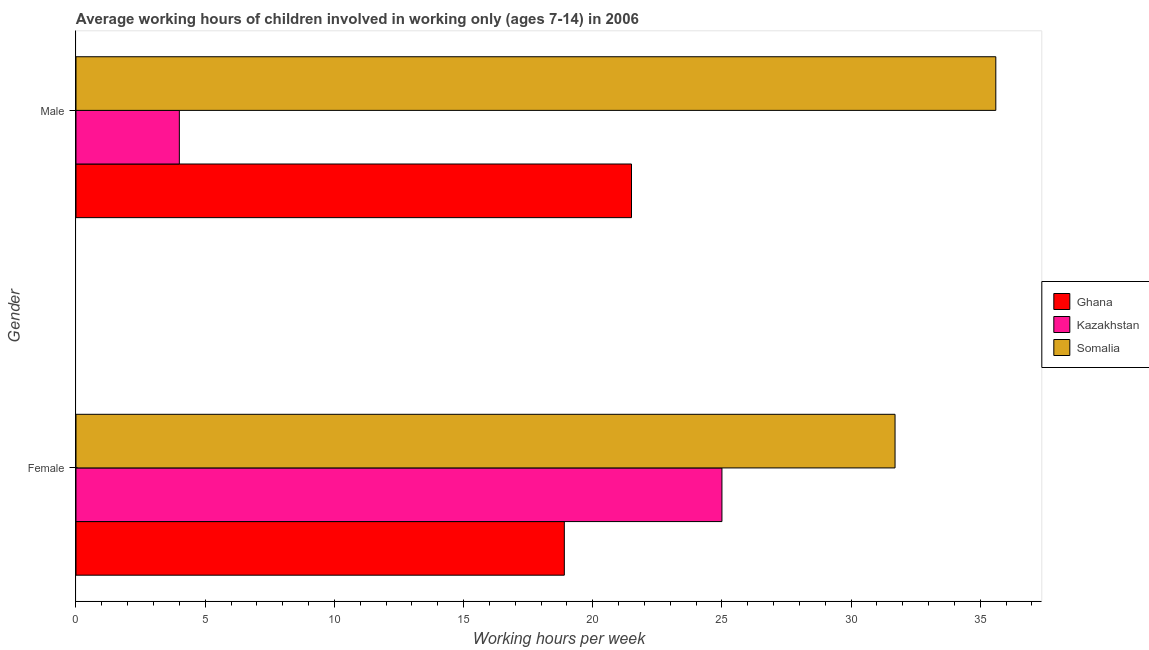Are the number of bars on each tick of the Y-axis equal?
Make the answer very short. Yes. How many bars are there on the 2nd tick from the bottom?
Offer a very short reply. 3. What is the label of the 1st group of bars from the top?
Give a very brief answer. Male. What is the average working hour of female children in Kazakhstan?
Your answer should be compact. 25. Across all countries, what is the maximum average working hour of male children?
Ensure brevity in your answer.  35.6. In which country was the average working hour of female children maximum?
Your answer should be very brief. Somalia. What is the total average working hour of female children in the graph?
Your response must be concise. 75.6. What is the difference between the average working hour of male children in Somalia and that in Kazakhstan?
Your answer should be compact. 31.6. What is the difference between the average working hour of male children in Kazakhstan and the average working hour of female children in Somalia?
Give a very brief answer. -27.7. What is the average average working hour of female children per country?
Provide a short and direct response. 25.2. What is the difference between the average working hour of male children and average working hour of female children in Ghana?
Make the answer very short. 2.6. What is the ratio of the average working hour of male children in Somalia to that in Ghana?
Keep it short and to the point. 1.66. In how many countries, is the average working hour of female children greater than the average average working hour of female children taken over all countries?
Your answer should be very brief. 1. What does the 3rd bar from the top in Male represents?
Provide a short and direct response. Ghana. What does the 3rd bar from the bottom in Female represents?
Your response must be concise. Somalia. How many bars are there?
Provide a short and direct response. 6. What is the difference between two consecutive major ticks on the X-axis?
Your answer should be compact. 5. Are the values on the major ticks of X-axis written in scientific E-notation?
Offer a terse response. No. Where does the legend appear in the graph?
Make the answer very short. Center right. How many legend labels are there?
Offer a terse response. 3. How are the legend labels stacked?
Provide a short and direct response. Vertical. What is the title of the graph?
Make the answer very short. Average working hours of children involved in working only (ages 7-14) in 2006. What is the label or title of the X-axis?
Offer a terse response. Working hours per week. What is the label or title of the Y-axis?
Keep it short and to the point. Gender. What is the Working hours per week in Kazakhstan in Female?
Ensure brevity in your answer.  25. What is the Working hours per week in Somalia in Female?
Provide a succinct answer. 31.7. What is the Working hours per week of Kazakhstan in Male?
Make the answer very short. 4. What is the Working hours per week of Somalia in Male?
Provide a short and direct response. 35.6. Across all Gender, what is the maximum Working hours per week of Ghana?
Make the answer very short. 21.5. Across all Gender, what is the maximum Working hours per week of Somalia?
Offer a very short reply. 35.6. Across all Gender, what is the minimum Working hours per week in Kazakhstan?
Your response must be concise. 4. Across all Gender, what is the minimum Working hours per week of Somalia?
Provide a short and direct response. 31.7. What is the total Working hours per week of Ghana in the graph?
Give a very brief answer. 40.4. What is the total Working hours per week of Somalia in the graph?
Make the answer very short. 67.3. What is the difference between the Working hours per week in Ghana in Female and the Working hours per week in Kazakhstan in Male?
Provide a short and direct response. 14.9. What is the difference between the Working hours per week in Ghana in Female and the Working hours per week in Somalia in Male?
Give a very brief answer. -16.7. What is the difference between the Working hours per week in Kazakhstan in Female and the Working hours per week in Somalia in Male?
Provide a succinct answer. -10.6. What is the average Working hours per week of Ghana per Gender?
Provide a short and direct response. 20.2. What is the average Working hours per week of Kazakhstan per Gender?
Provide a succinct answer. 14.5. What is the average Working hours per week in Somalia per Gender?
Your answer should be very brief. 33.65. What is the difference between the Working hours per week in Ghana and Working hours per week in Somalia in Male?
Your response must be concise. -14.1. What is the difference between the Working hours per week of Kazakhstan and Working hours per week of Somalia in Male?
Your response must be concise. -31.6. What is the ratio of the Working hours per week in Ghana in Female to that in Male?
Give a very brief answer. 0.88. What is the ratio of the Working hours per week of Kazakhstan in Female to that in Male?
Keep it short and to the point. 6.25. What is the ratio of the Working hours per week of Somalia in Female to that in Male?
Offer a terse response. 0.89. What is the difference between the highest and the second highest Working hours per week in Ghana?
Offer a terse response. 2.6. What is the difference between the highest and the second highest Working hours per week of Kazakhstan?
Provide a succinct answer. 21. What is the difference between the highest and the lowest Working hours per week of Ghana?
Ensure brevity in your answer.  2.6. What is the difference between the highest and the lowest Working hours per week in Kazakhstan?
Give a very brief answer. 21. 